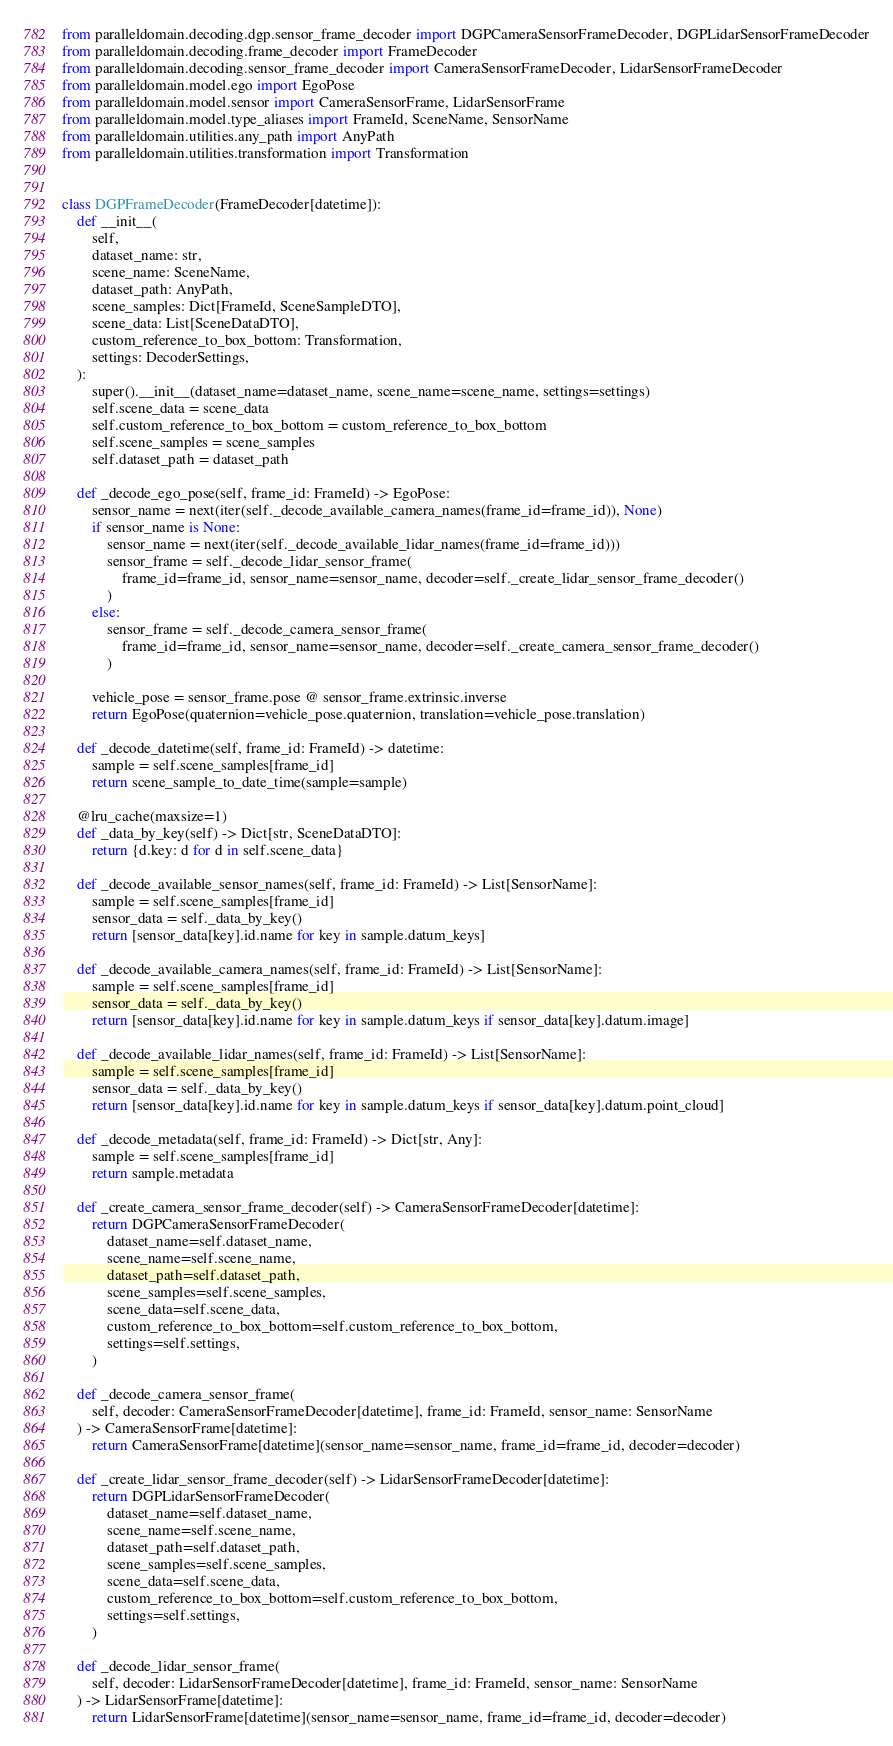Convert code to text. <code><loc_0><loc_0><loc_500><loc_500><_Python_>from paralleldomain.decoding.dgp.sensor_frame_decoder import DGPCameraSensorFrameDecoder, DGPLidarSensorFrameDecoder
from paralleldomain.decoding.frame_decoder import FrameDecoder
from paralleldomain.decoding.sensor_frame_decoder import CameraSensorFrameDecoder, LidarSensorFrameDecoder
from paralleldomain.model.ego import EgoPose
from paralleldomain.model.sensor import CameraSensorFrame, LidarSensorFrame
from paralleldomain.model.type_aliases import FrameId, SceneName, SensorName
from paralleldomain.utilities.any_path import AnyPath
from paralleldomain.utilities.transformation import Transformation


class DGPFrameDecoder(FrameDecoder[datetime]):
    def __init__(
        self,
        dataset_name: str,
        scene_name: SceneName,
        dataset_path: AnyPath,
        scene_samples: Dict[FrameId, SceneSampleDTO],
        scene_data: List[SceneDataDTO],
        custom_reference_to_box_bottom: Transformation,
        settings: DecoderSettings,
    ):
        super().__init__(dataset_name=dataset_name, scene_name=scene_name, settings=settings)
        self.scene_data = scene_data
        self.custom_reference_to_box_bottom = custom_reference_to_box_bottom
        self.scene_samples = scene_samples
        self.dataset_path = dataset_path

    def _decode_ego_pose(self, frame_id: FrameId) -> EgoPose:
        sensor_name = next(iter(self._decode_available_camera_names(frame_id=frame_id)), None)
        if sensor_name is None:
            sensor_name = next(iter(self._decode_available_lidar_names(frame_id=frame_id)))
            sensor_frame = self._decode_lidar_sensor_frame(
                frame_id=frame_id, sensor_name=sensor_name, decoder=self._create_lidar_sensor_frame_decoder()
            )
        else:
            sensor_frame = self._decode_camera_sensor_frame(
                frame_id=frame_id, sensor_name=sensor_name, decoder=self._create_camera_sensor_frame_decoder()
            )

        vehicle_pose = sensor_frame.pose @ sensor_frame.extrinsic.inverse
        return EgoPose(quaternion=vehicle_pose.quaternion, translation=vehicle_pose.translation)

    def _decode_datetime(self, frame_id: FrameId) -> datetime:
        sample = self.scene_samples[frame_id]
        return scene_sample_to_date_time(sample=sample)

    @lru_cache(maxsize=1)
    def _data_by_key(self) -> Dict[str, SceneDataDTO]:
        return {d.key: d for d in self.scene_data}

    def _decode_available_sensor_names(self, frame_id: FrameId) -> List[SensorName]:
        sample = self.scene_samples[frame_id]
        sensor_data = self._data_by_key()
        return [sensor_data[key].id.name for key in sample.datum_keys]

    def _decode_available_camera_names(self, frame_id: FrameId) -> List[SensorName]:
        sample = self.scene_samples[frame_id]
        sensor_data = self._data_by_key()
        return [sensor_data[key].id.name for key in sample.datum_keys if sensor_data[key].datum.image]

    def _decode_available_lidar_names(self, frame_id: FrameId) -> List[SensorName]:
        sample = self.scene_samples[frame_id]
        sensor_data = self._data_by_key()
        return [sensor_data[key].id.name for key in sample.datum_keys if sensor_data[key].datum.point_cloud]

    def _decode_metadata(self, frame_id: FrameId) -> Dict[str, Any]:
        sample = self.scene_samples[frame_id]
        return sample.metadata

    def _create_camera_sensor_frame_decoder(self) -> CameraSensorFrameDecoder[datetime]:
        return DGPCameraSensorFrameDecoder(
            dataset_name=self.dataset_name,
            scene_name=self.scene_name,
            dataset_path=self.dataset_path,
            scene_samples=self.scene_samples,
            scene_data=self.scene_data,
            custom_reference_to_box_bottom=self.custom_reference_to_box_bottom,
            settings=self.settings,
        )

    def _decode_camera_sensor_frame(
        self, decoder: CameraSensorFrameDecoder[datetime], frame_id: FrameId, sensor_name: SensorName
    ) -> CameraSensorFrame[datetime]:
        return CameraSensorFrame[datetime](sensor_name=sensor_name, frame_id=frame_id, decoder=decoder)

    def _create_lidar_sensor_frame_decoder(self) -> LidarSensorFrameDecoder[datetime]:
        return DGPLidarSensorFrameDecoder(
            dataset_name=self.dataset_name,
            scene_name=self.scene_name,
            dataset_path=self.dataset_path,
            scene_samples=self.scene_samples,
            scene_data=self.scene_data,
            custom_reference_to_box_bottom=self.custom_reference_to_box_bottom,
            settings=self.settings,
        )

    def _decode_lidar_sensor_frame(
        self, decoder: LidarSensorFrameDecoder[datetime], frame_id: FrameId, sensor_name: SensorName
    ) -> LidarSensorFrame[datetime]:
        return LidarSensorFrame[datetime](sensor_name=sensor_name, frame_id=frame_id, decoder=decoder)
</code> 